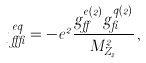Convert formula to latex. <formula><loc_0><loc_0><loc_500><loc_500>\eta _ { \alpha \beta } ^ { e q } = - e ^ { 2 } \frac { g _ { \alpha } ^ { e ( 2 ) } g _ { \beta } ^ { q ( 2 ) } } { M _ { Z _ { 2 } } ^ { 2 } } \, ,</formula> 